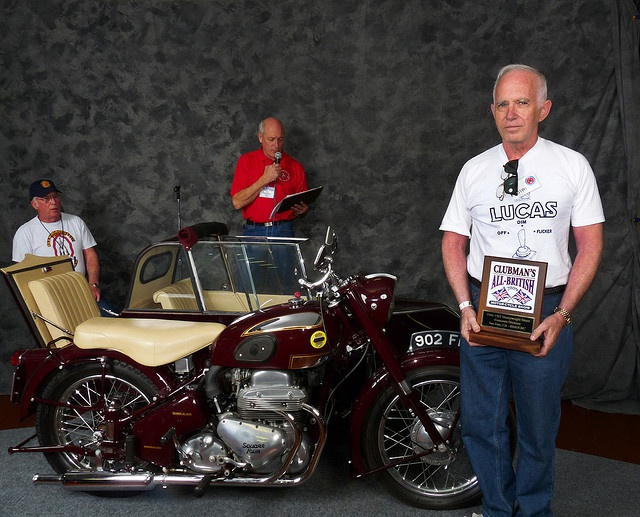Describe the objects in this image and their specific colors. I can see motorcycle in black, gray, tan, and darkgray tones, people in black, white, navy, and brown tones, people in black, brown, and maroon tones, people in black, lightgray, brown, and darkgray tones, and book in black, white, gray, and maroon tones in this image. 